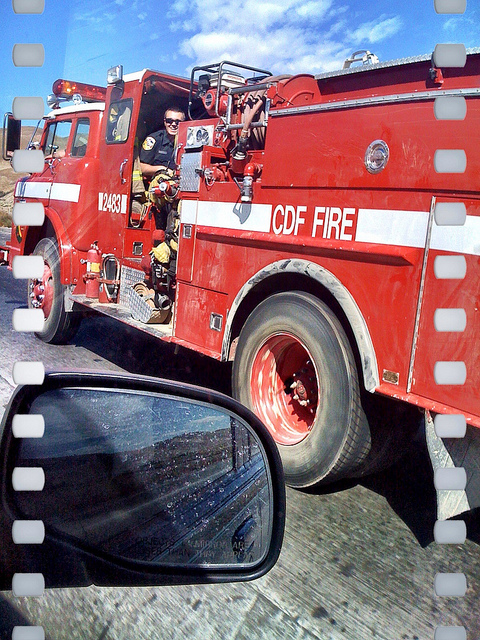What do the letters 'CDF' on the fire truck stand for? 'CDF' stands for 'California Department of Forestry' which is often associated with fire services in California, dealing with wildfires and other emergencies related to forestry. 